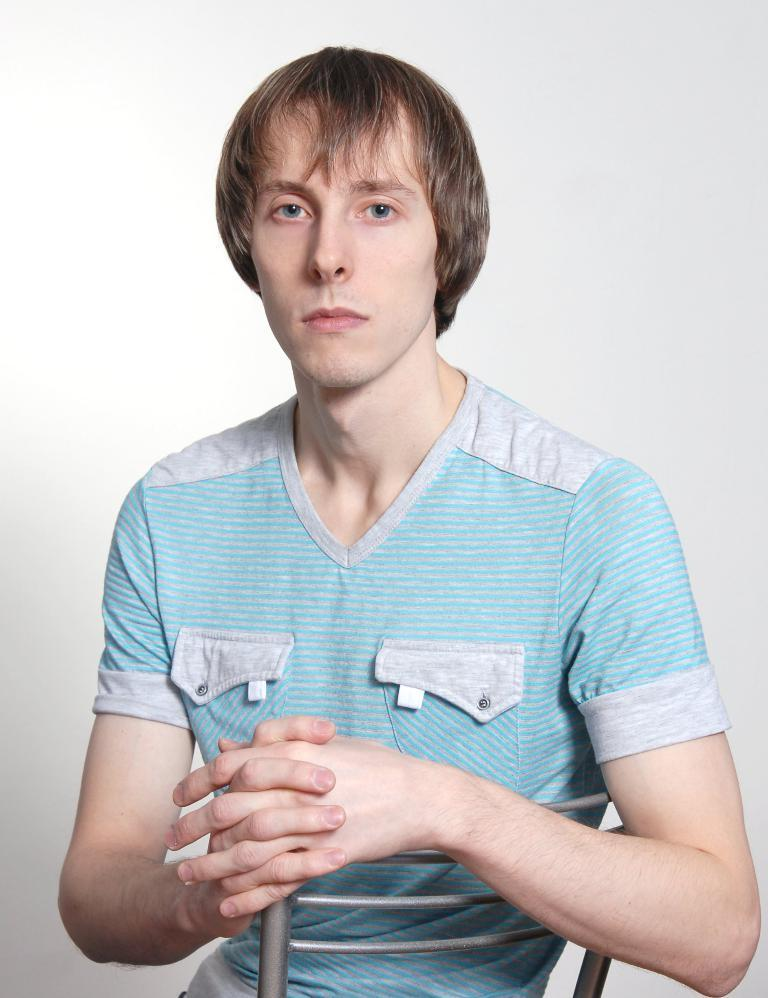What is the person in the image doing? The person is sitting on a chair in the image. What is the person wearing? The person is wearing a blue dress. What can be seen in the background of the image? There is a white wall visible in the background of the image. What type of beetle can be seen crawling on the person's dress in the image? There is no beetle present on the person's dress in the image. Can you tell me how the person is preparing for their flight in the image? The image does not depict a flight or any preparations for one. 